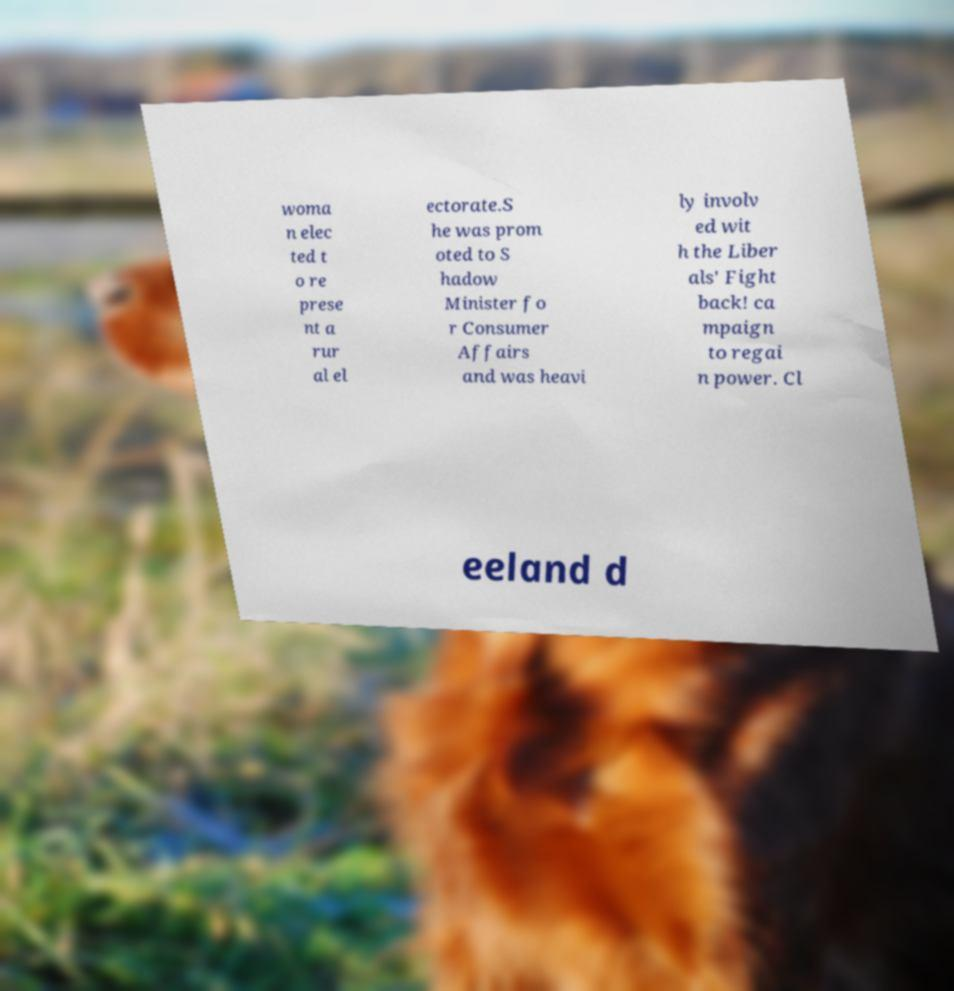There's text embedded in this image that I need extracted. Can you transcribe it verbatim? woma n elec ted t o re prese nt a rur al el ectorate.S he was prom oted to S hadow Minister fo r Consumer Affairs and was heavi ly involv ed wit h the Liber als' Fight back! ca mpaign to regai n power. Cl eeland d 